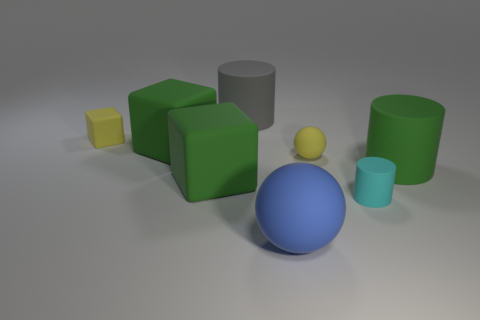What is the size of the matte block that is the same color as the tiny sphere?
Give a very brief answer. Small. What is the color of the matte cylinder that is the same size as the yellow ball?
Offer a terse response. Cyan. There is a matte object that is the same color as the small matte ball; what shape is it?
Your answer should be compact. Cube. Is the large blue matte object the same shape as the big gray object?
Your response must be concise. No. The thing that is in front of the big green matte cylinder and on the right side of the small ball is made of what material?
Offer a terse response. Rubber. What size is the blue rubber sphere?
Your answer should be compact. Large. There is another big object that is the same shape as the large gray matte object; what is its color?
Ensure brevity in your answer.  Green. Is there anything else that has the same color as the small cylinder?
Give a very brief answer. No. Is the size of the matte thing that is to the right of the cyan cylinder the same as the cylinder behind the yellow ball?
Provide a short and direct response. Yes. Are there an equal number of yellow balls that are on the right side of the small cyan object and matte cylinders to the left of the gray cylinder?
Your answer should be very brief. Yes. 